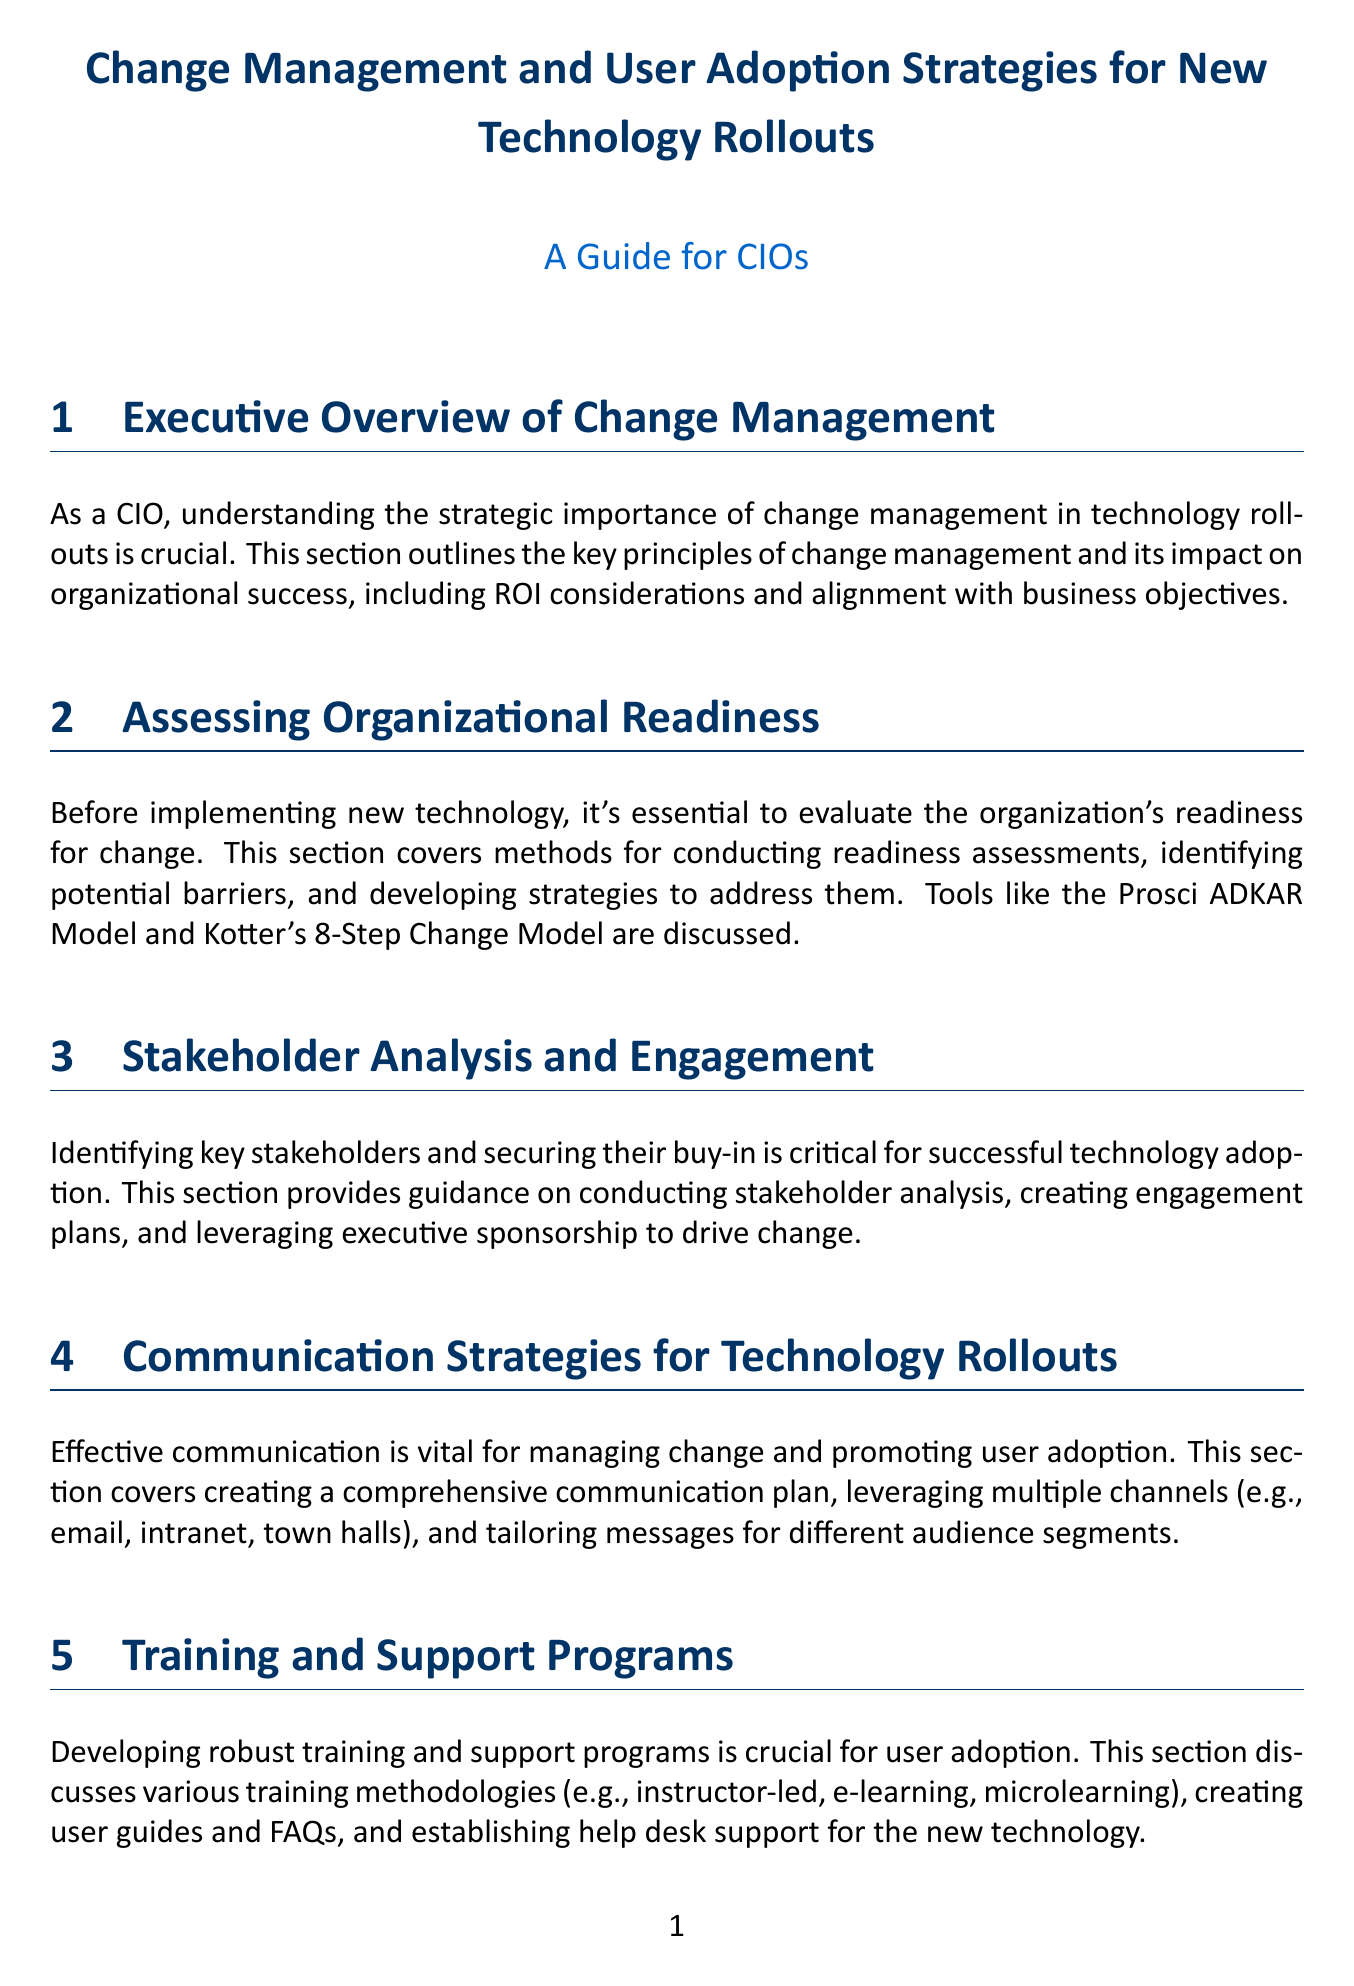What is the importance of change management in technology rollouts? The document states that understanding the strategic importance of change management is crucial for organizational success, including ROI considerations and alignment with business objectives.
Answer: Strategic importance What is assessed before implementing new technology? The document emphasizes evaluating the organization's readiness for change as essential before implementing new technology.
Answer: Organizational readiness Which model is discussed for readiness assessments? The section on assessing organizational readiness mentions tools like the Prosci ADKAR Model for conducting assessments.
Answer: Prosci ADKAR Model What strategies are covered for addressing resistance? The document includes strategies for identifying and addressing resistance using the SCARF model techniques.
Answer: SCARF model What type of training methodologies are discussed? Various training methodologies such as instructor-led, e-learning, and microlearning are discussed for user adoption.
Answer: Instructor-led, e-learning, microlearning What key performance indicators are relevant for measuring adoption? The document mentions user engagement, productivity improvements, and cost savings as key performance indicators for measuring adoption.
Answer: User engagement, productivity improvements, cost savings How can change champions impact technology adoption? The document states that identifying and empowering change champions can significantly boost adoption rates within the organization.
Answer: Boost adoption rates What types of feedback mechanisms are essential for long-term success? Establishing mechanisms for continuous improvement and feedback is mentioned as essential for long-term success in the document.
Answer: Continuous improvement and feedback What is the focus of the case studies section? The case studies section presents successful technology rollouts to highlight key strategies and lessons learned from real-world examples.
Answer: Successful technology rollouts 